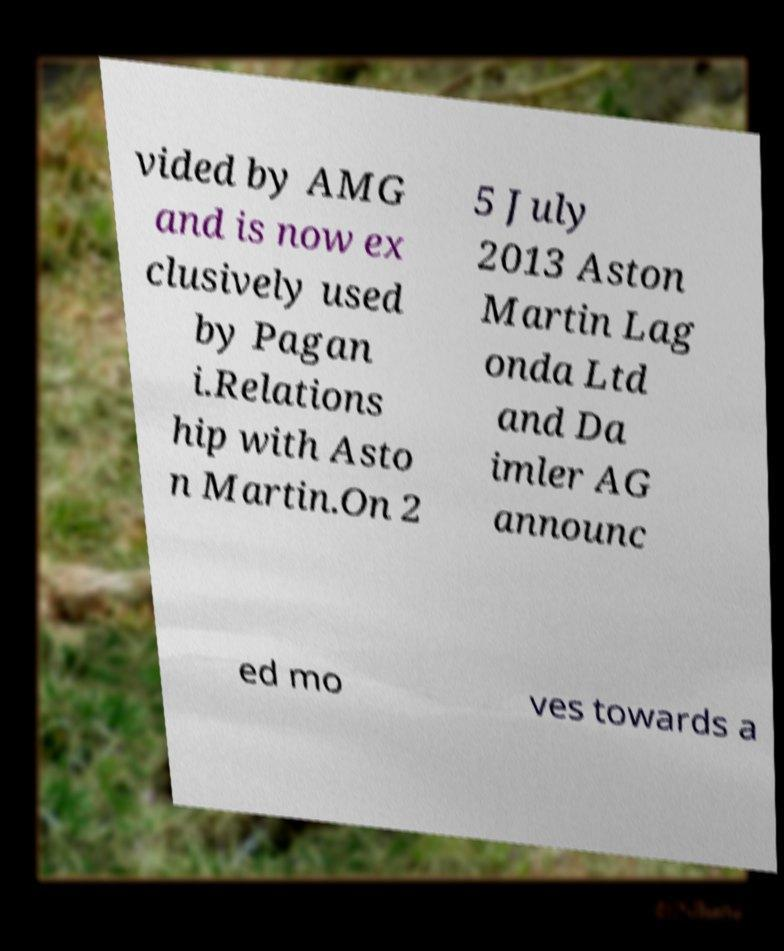I need the written content from this picture converted into text. Can you do that? vided by AMG and is now ex clusively used by Pagan i.Relations hip with Asto n Martin.On 2 5 July 2013 Aston Martin Lag onda Ltd and Da imler AG announc ed mo ves towards a 